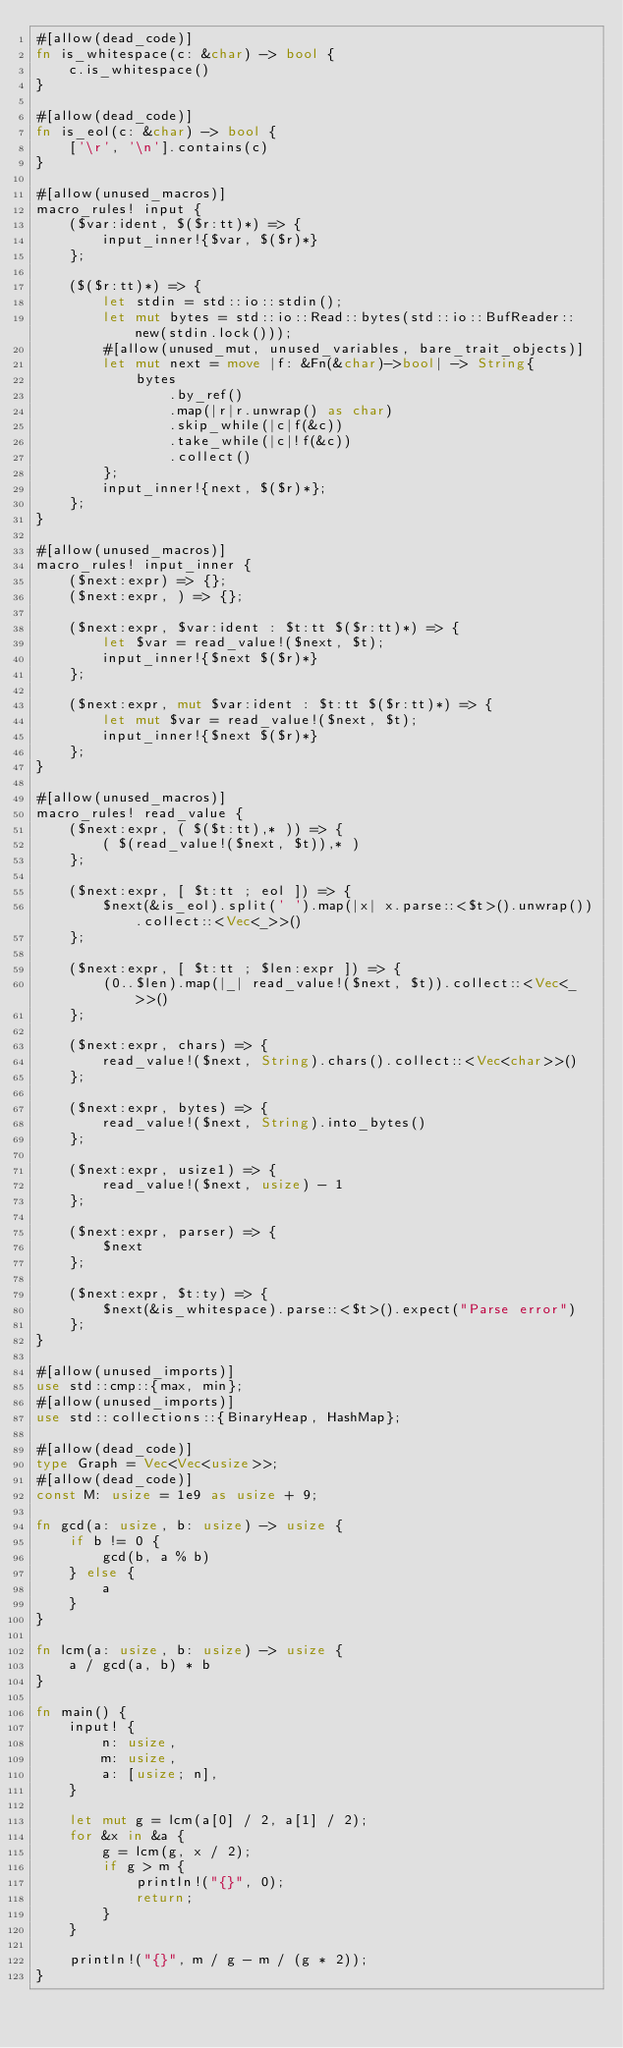<code> <loc_0><loc_0><loc_500><loc_500><_Rust_>#[allow(dead_code)]
fn is_whitespace(c: &char) -> bool {
    c.is_whitespace()
}

#[allow(dead_code)]
fn is_eol(c: &char) -> bool {
    ['\r', '\n'].contains(c)
}

#[allow(unused_macros)]
macro_rules! input {
    ($var:ident, $($r:tt)*) => {
        input_inner!{$var, $($r)*}
    };

    ($($r:tt)*) => {
        let stdin = std::io::stdin();
        let mut bytes = std::io::Read::bytes(std::io::BufReader::new(stdin.lock()));
        #[allow(unused_mut, unused_variables, bare_trait_objects)]
        let mut next = move |f: &Fn(&char)->bool| -> String{
            bytes
                .by_ref()
                .map(|r|r.unwrap() as char)
                .skip_while(|c|f(&c))
                .take_while(|c|!f(&c))
                .collect()
        };
        input_inner!{next, $($r)*};
    };
}

#[allow(unused_macros)]
macro_rules! input_inner {
    ($next:expr) => {};
    ($next:expr, ) => {};

    ($next:expr, $var:ident : $t:tt $($r:tt)*) => {
        let $var = read_value!($next, $t);
        input_inner!{$next $($r)*}
    };

    ($next:expr, mut $var:ident : $t:tt $($r:tt)*) => {
        let mut $var = read_value!($next, $t);
        input_inner!{$next $($r)*}
    };
}

#[allow(unused_macros)]
macro_rules! read_value {
    ($next:expr, ( $($t:tt),* )) => {
        ( $(read_value!($next, $t)),* )
    };

    ($next:expr, [ $t:tt ; eol ]) => {
        $next(&is_eol).split(' ').map(|x| x.parse::<$t>().unwrap()).collect::<Vec<_>>()
    };

    ($next:expr, [ $t:tt ; $len:expr ]) => {
        (0..$len).map(|_| read_value!($next, $t)).collect::<Vec<_>>()
    };

    ($next:expr, chars) => {
        read_value!($next, String).chars().collect::<Vec<char>>()
    };

    ($next:expr, bytes) => {
        read_value!($next, String).into_bytes()
    };

    ($next:expr, usize1) => {
        read_value!($next, usize) - 1
    };

    ($next:expr, parser) => {
        $next
    };

    ($next:expr, $t:ty) => {
        $next(&is_whitespace).parse::<$t>().expect("Parse error")
    };
}

#[allow(unused_imports)]
use std::cmp::{max, min};
#[allow(unused_imports)]
use std::collections::{BinaryHeap, HashMap};

#[allow(dead_code)]
type Graph = Vec<Vec<usize>>;
#[allow(dead_code)]
const M: usize = 1e9 as usize + 9;

fn gcd(a: usize, b: usize) -> usize {
    if b != 0 {
        gcd(b, a % b)
    } else {
        a
    }
}

fn lcm(a: usize, b: usize) -> usize {
    a / gcd(a, b) * b
}

fn main() {
    input! {
        n: usize,
        m: usize,
        a: [usize; n],
    }

    let mut g = lcm(a[0] / 2, a[1] / 2);
    for &x in &a {
        g = lcm(g, x / 2);
        if g > m {
            println!("{}", 0);
            return;
        }
    }

    println!("{}", m / g - m / (g * 2));
}
</code> 